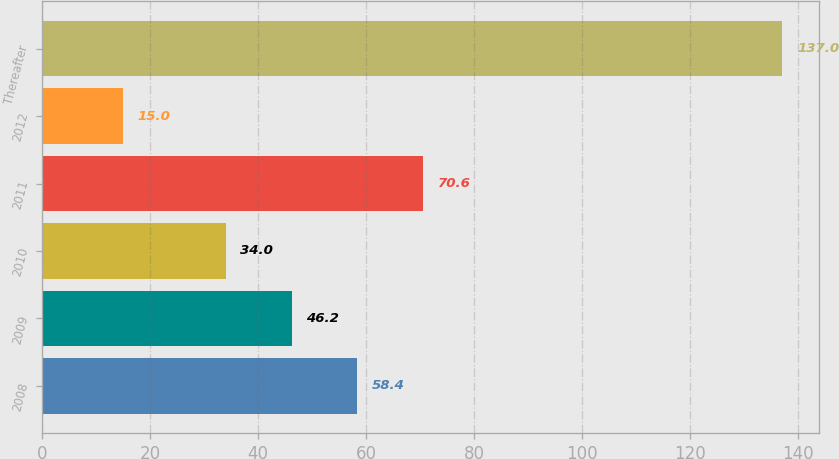Convert chart. <chart><loc_0><loc_0><loc_500><loc_500><bar_chart><fcel>2008<fcel>2009<fcel>2010<fcel>2011<fcel>2012<fcel>Thereafter<nl><fcel>58.4<fcel>46.2<fcel>34<fcel>70.6<fcel>15<fcel>137<nl></chart> 